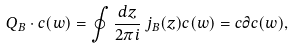Convert formula to latex. <formula><loc_0><loc_0><loc_500><loc_500>Q _ { B } \cdot c ( w ) = \oint \frac { d z } { 2 \pi i } \, j _ { B } ( z ) c ( w ) = c \partial c ( w ) ,</formula> 